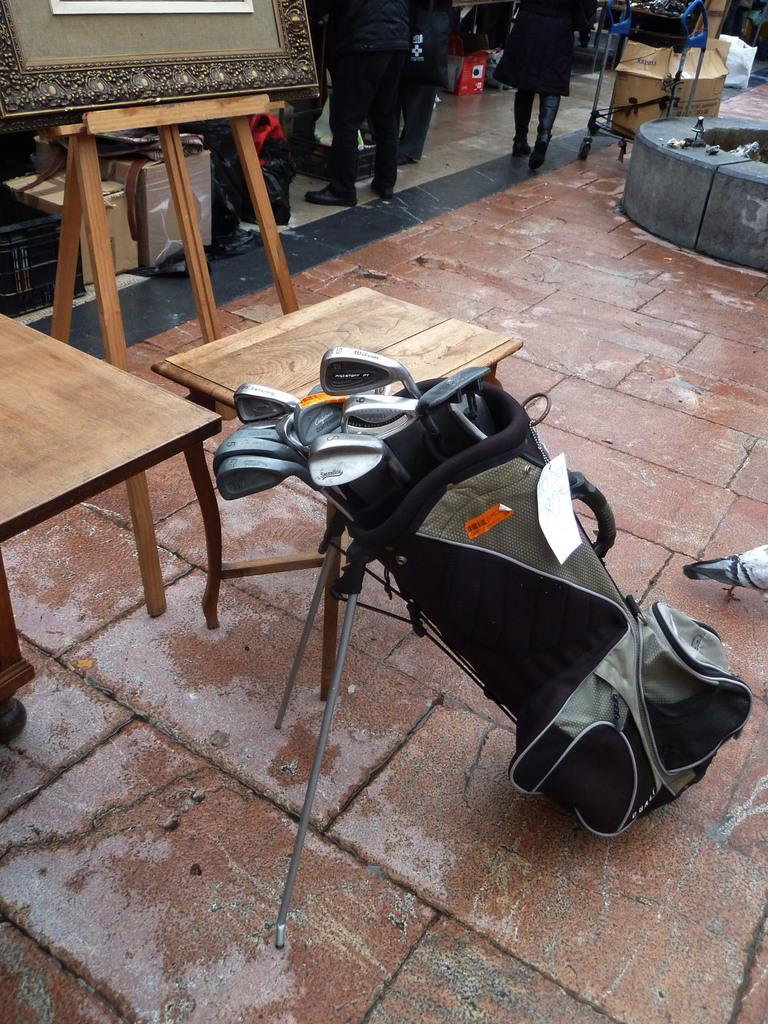What object is present in the image that can hold items? There is a bag in the image that can hold items. What is inside the bag in the image? There are bats in the bag. What can be seen in the background of the image? There is a table and a board in the background of the image. Are there any people visible in the image? Yes, there are persons standing in the background of the image. What type of ink is being used by the person holding the bag in the image? There is no indication in the image that a person is holding the bag or using ink. 